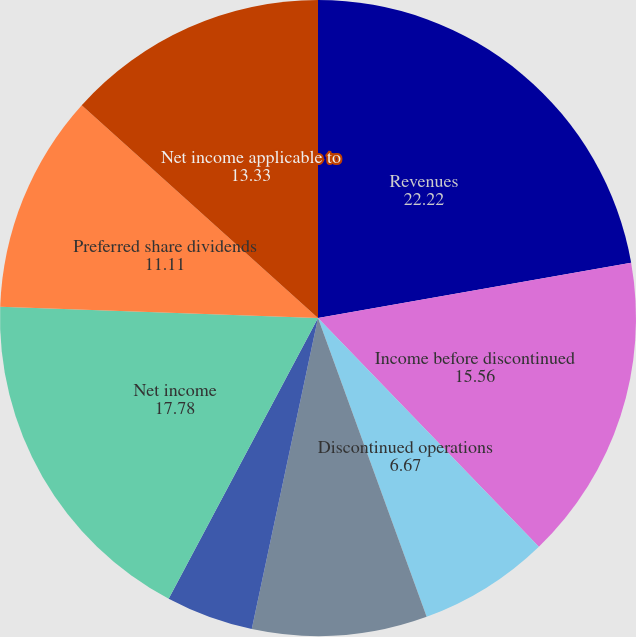<chart> <loc_0><loc_0><loc_500><loc_500><pie_chart><fcel>Revenues<fcel>Income before discontinued<fcel>Discontinued operations<fcel>Gains on sale of real estate<fcel>Cumulative effect of change in<fcel>Net income<fcel>Preferred share dividends<fcel>Net income applicable to<fcel>Net income per common<nl><fcel>22.22%<fcel>15.56%<fcel>6.67%<fcel>8.89%<fcel>4.44%<fcel>17.78%<fcel>11.11%<fcel>13.33%<fcel>0.0%<nl></chart> 